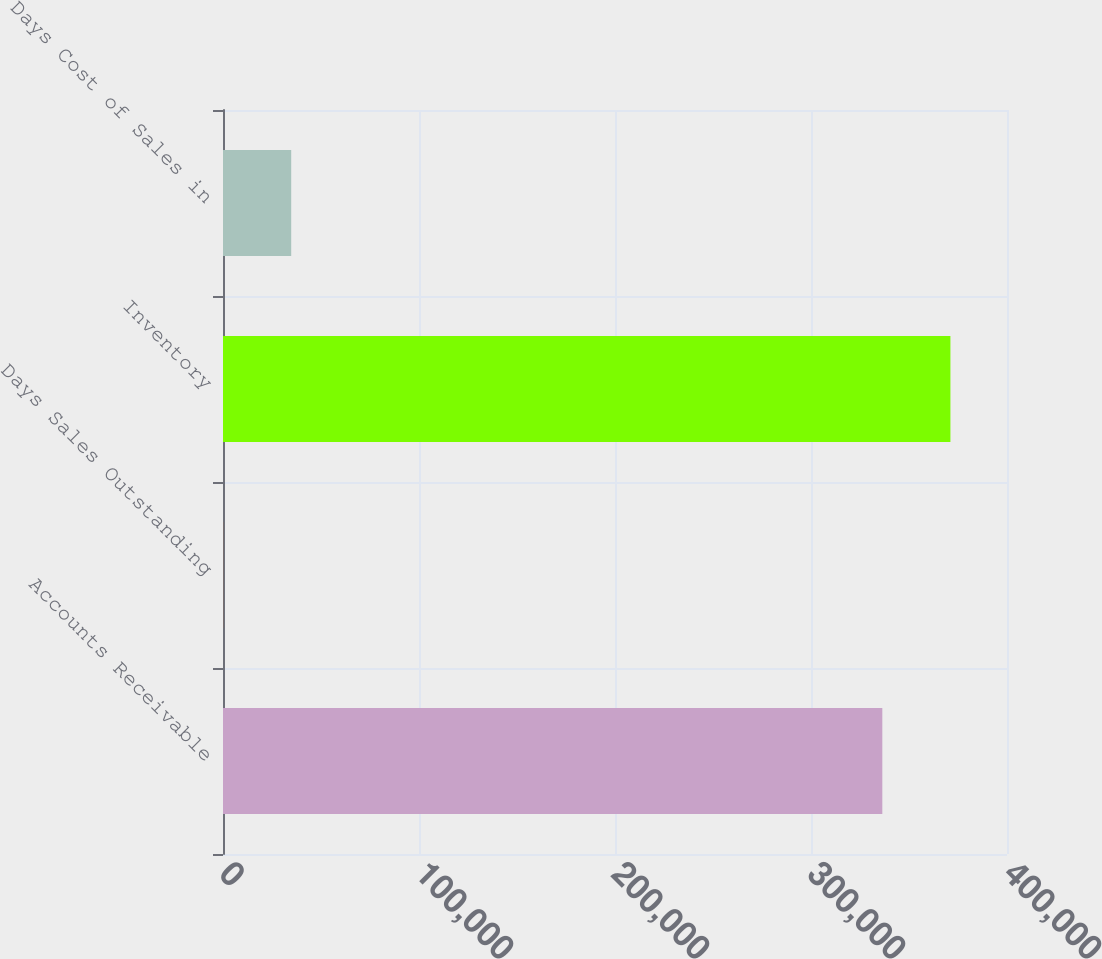Convert chart to OTSL. <chart><loc_0><loc_0><loc_500><loc_500><bar_chart><fcel>Accounts Receivable<fcel>Days Sales Outstanding<fcel>Inventory<fcel>Days Cost of Sales in<nl><fcel>336381<fcel>47<fcel>371128<fcel>34794.2<nl></chart> 